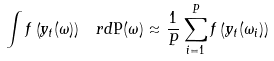<formula> <loc_0><loc_0><loc_500><loc_500>\int f \left ( y _ { t } ( \omega ) \right ) \, \ r d \mathsf P ( \omega ) \approx \frac { 1 } { P } \sum _ { i = 1 } ^ { P } f \left ( y _ { t } ( \omega _ { i } ) \right )</formula> 